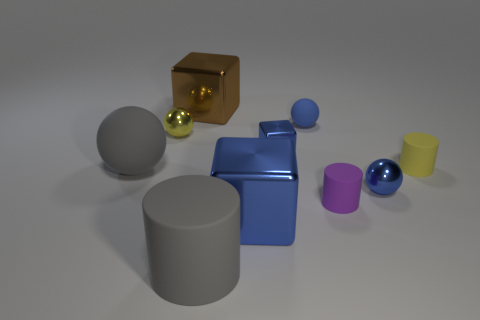Subtract all small matte cylinders. How many cylinders are left? 1 Subtract all green balls. How many blue cubes are left? 2 Subtract all gray cylinders. How many cylinders are left? 2 Subtract all blocks. How many objects are left? 7 Subtract 2 blocks. How many blocks are left? 1 Subtract all green cylinders. Subtract all green balls. How many cylinders are left? 3 Subtract all big gray things. Subtract all metallic cubes. How many objects are left? 5 Add 3 purple rubber things. How many purple rubber things are left? 4 Add 6 yellow things. How many yellow things exist? 8 Subtract 0 red cylinders. How many objects are left? 10 